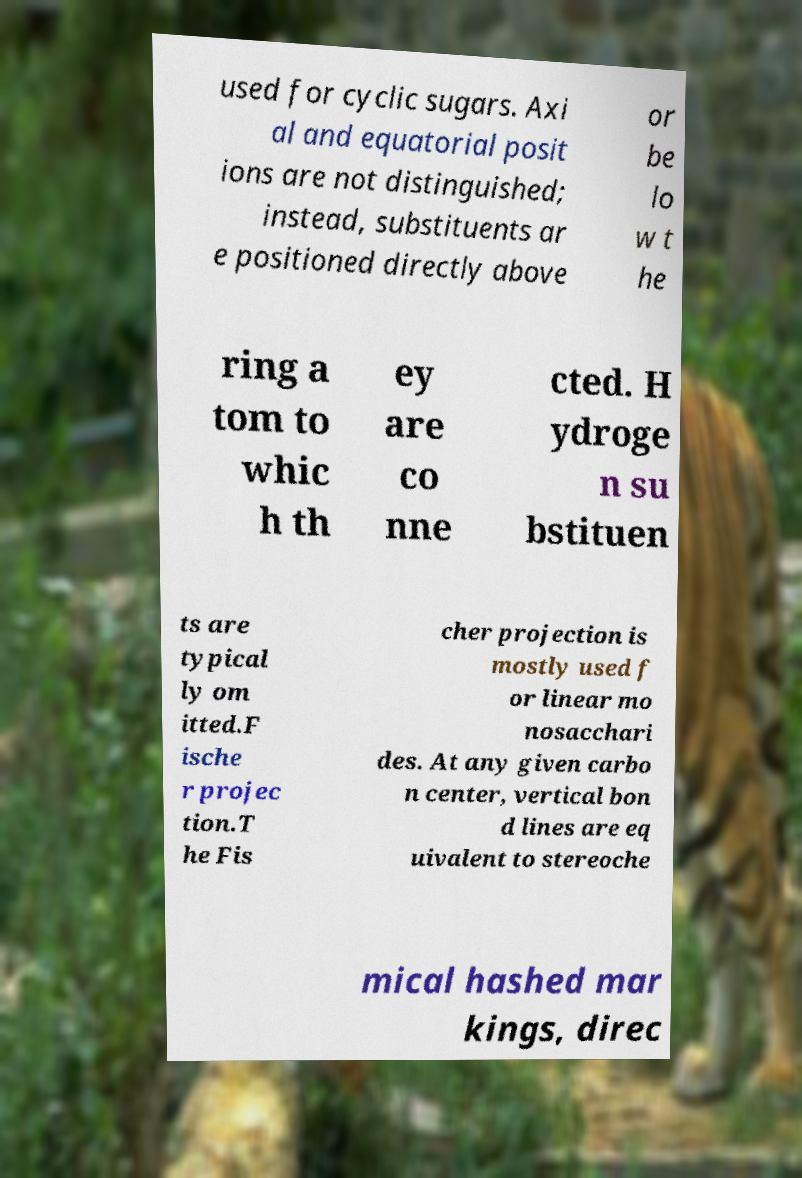Can you read and provide the text displayed in the image?This photo seems to have some interesting text. Can you extract and type it out for me? used for cyclic sugars. Axi al and equatorial posit ions are not distinguished; instead, substituents ar e positioned directly above or be lo w t he ring a tom to whic h th ey are co nne cted. H ydroge n su bstituen ts are typical ly om itted.F ische r projec tion.T he Fis cher projection is mostly used f or linear mo nosacchari des. At any given carbo n center, vertical bon d lines are eq uivalent to stereoche mical hashed mar kings, direc 